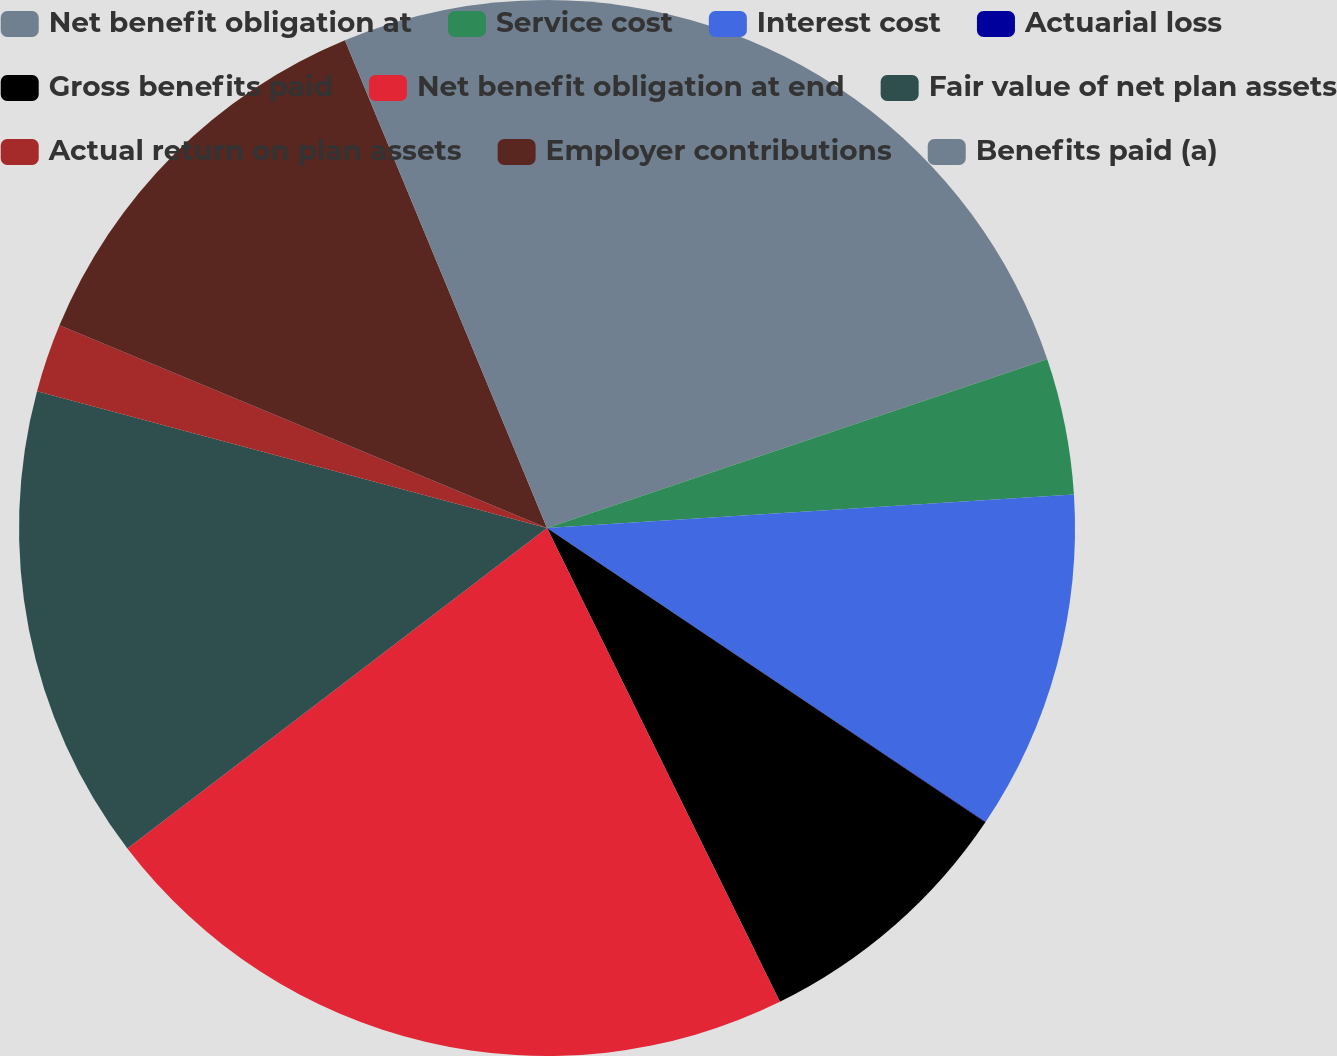Convert chart. <chart><loc_0><loc_0><loc_500><loc_500><pie_chart><fcel>Net benefit obligation at<fcel>Service cost<fcel>Interest cost<fcel>Actuarial loss<fcel>Gross benefits paid<fcel>Net benefit obligation at end<fcel>Fair value of net plan assets<fcel>Actual return on plan assets<fcel>Employer contributions<fcel>Benefits paid (a)<nl><fcel>19.82%<fcel>4.17%<fcel>10.4%<fcel>0.02%<fcel>8.32%<fcel>21.89%<fcel>14.55%<fcel>2.1%<fcel>12.48%<fcel>6.25%<nl></chart> 